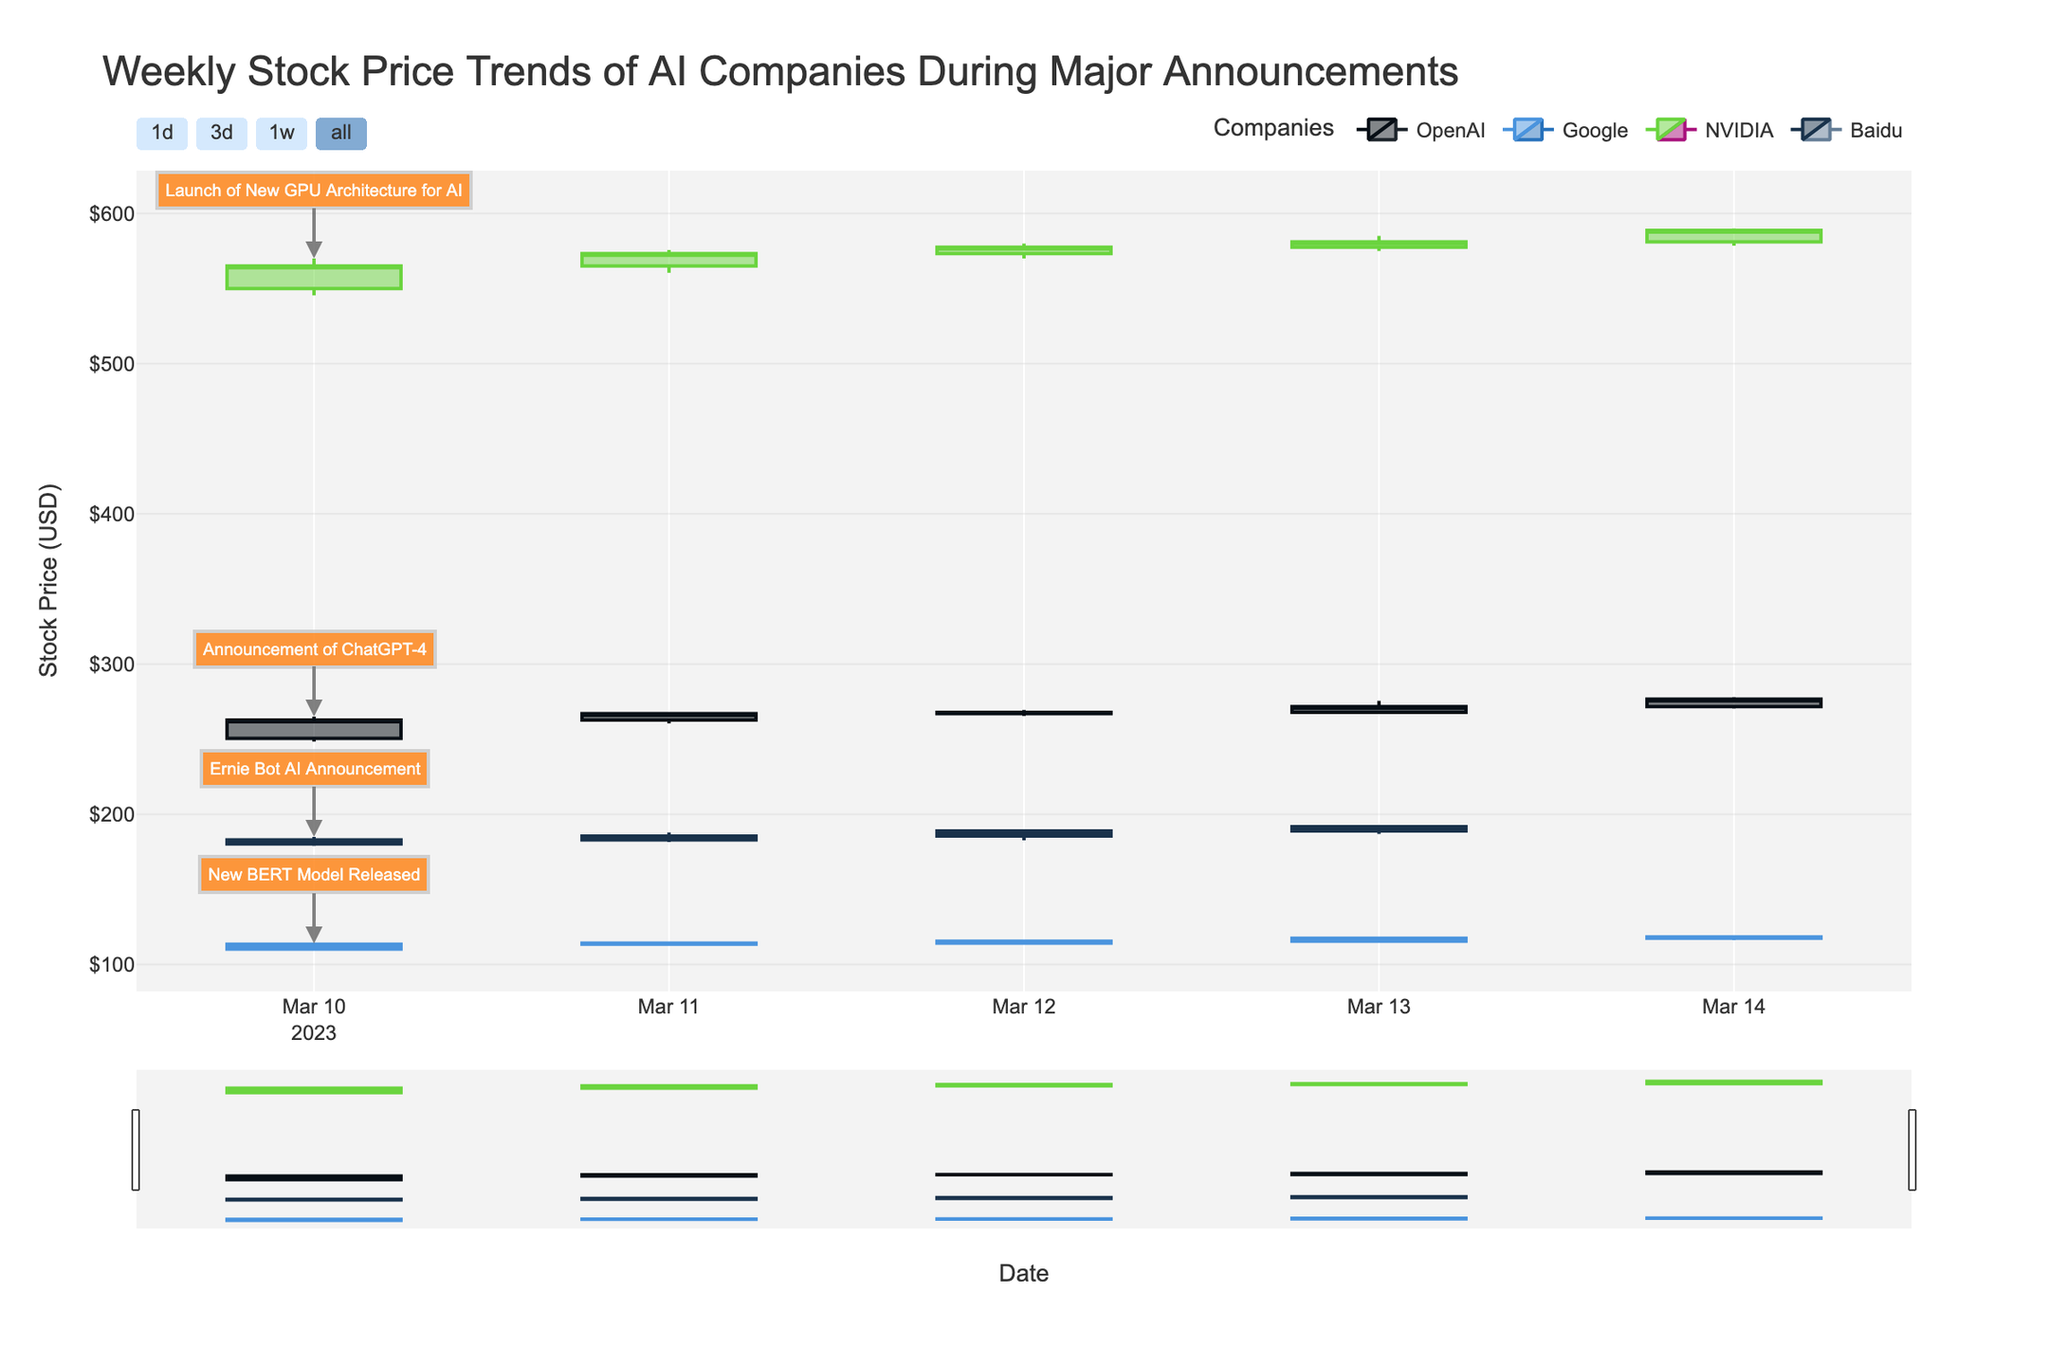¿Qué empresa tuvo el mayor aumento en su precio de cierre durante la semana? Para encontrar la empresa con el mayor aumento en el precio de cierre, revisamos el precio de cierre del primer y último día de cada empresa. OpenAI pasó de $262.75 a $276.70, Google de $113.50 a $118.40, NVIDIA de $565.00 a $588.70, y Baidu de $183.00 a $191.75. Calculamos los aumentos: OpenAI ($276.70 - $262.75 = $13.95), Google ($118.40 - $113.50 = $4.90), NVIDIA ($588.70 - $565.00 = $23.70), y Baidu ($191.75 - $183.00 = $8.75). La empresa que tuvo el mayor aumento es NVIDIA con $23.70.
Answer: NVIDIA ¿Qué día OpenAI tuvo el volumen de transacciones más alto? Revisamos los valores en la columna de Volumen para OpenAI en cada día. El volumen más alto para OpenAI fue el 10 de marzo con 15,800,000 transacciones.
Answer: 10 de marzo ¿Cómo se comparan los precios de cierre de Google y Baidu el 12 de marzo? Para comparar, revisamos los precios de cierre de Google y Baidu el 12 de marzo. El cierre de Google fue de $115.50 y el de Baidu fue de $189.00. Google cerró más bajo que Baidu.
Answer: Baidu cerró más alto ¿Cuál es la diferencia en el precio más bajo y más alto de NVIDIA el 13 de marzo? Tomamos el precio más bajo ($575.00) y el precio más alto ($585.00) de NVIDIA el 13 de marzo. Calculamos la diferencia restando el menor al mayor: $585.00 - $575.00 = $10.00.
Answer: $10.00 ¿Cuándo fue anunciado el lanzamiento de ChatGPT-4 y cómo afectó el precio de apertura al día siguiente? Revisamos los eventos y notamos que el lanzamiento de ChatGPT-4 por OpenAI fue el 10 de marzo. El precio de apertura el 10 de marzo fue $250.50 y el precio de apertura al día siguiente fue $262.75, lo cual muestra un aumento.
Answer: 10 de marzo, aumento ¿En qué semana día Baidu tuvo el precio de cierre más alto y cuál fue ese precio? Revisamos los precios de cierre de Baidu para cada día. El cierre más alto fue el 13 de marzo con un precio de $191.75.
Answer: 13 de marzo, $191.75 ¿Cuál fue el cambio neto en el precio de Google del 10 al 14 de marzo? Para hallar el cambio neto en el precio de Google entre estos días, restamos el precio de cierre del 10 de marzo ($113.50) al del 14 de marzo ($118.40): $118.40 - $113.50 = $4.90.
Answer: $4.90 